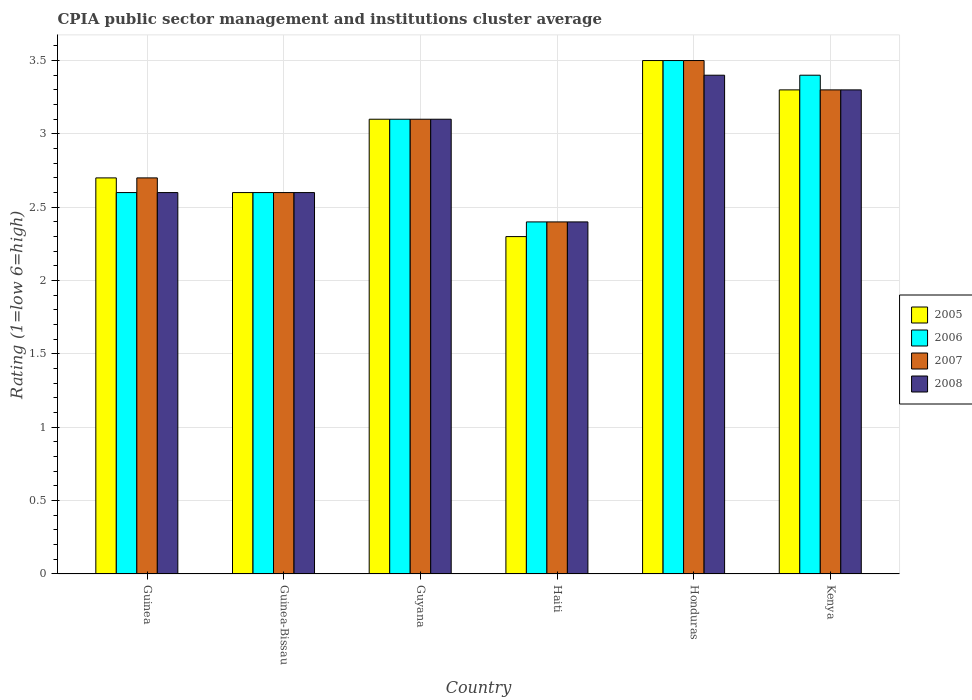Are the number of bars per tick equal to the number of legend labels?
Provide a succinct answer. Yes. Are the number of bars on each tick of the X-axis equal?
Your response must be concise. Yes. How many bars are there on the 1st tick from the left?
Your answer should be compact. 4. What is the label of the 3rd group of bars from the left?
Give a very brief answer. Guyana. In how many cases, is the number of bars for a given country not equal to the number of legend labels?
Offer a terse response. 0. What is the CPIA rating in 2005 in Guinea-Bissau?
Offer a very short reply. 2.6. Across all countries, what is the maximum CPIA rating in 2008?
Your response must be concise. 3.4. Across all countries, what is the minimum CPIA rating in 2008?
Offer a very short reply. 2.4. In which country was the CPIA rating in 2008 maximum?
Ensure brevity in your answer.  Honduras. In which country was the CPIA rating in 2006 minimum?
Provide a short and direct response. Haiti. What is the difference between the CPIA rating in 2005 in Guinea and that in Kenya?
Offer a very short reply. -0.6. What is the difference between the CPIA rating in 2007 in Guyana and the CPIA rating in 2005 in Kenya?
Your answer should be compact. -0.2. What is the average CPIA rating in 2007 per country?
Offer a very short reply. 2.93. What is the ratio of the CPIA rating in 2005 in Haiti to that in Honduras?
Give a very brief answer. 0.66. Is the CPIA rating in 2006 in Guinea less than that in Guyana?
Offer a very short reply. Yes. What is the difference between the highest and the second highest CPIA rating in 2007?
Your answer should be very brief. -0.2. In how many countries, is the CPIA rating in 2005 greater than the average CPIA rating in 2005 taken over all countries?
Your answer should be very brief. 3. What does the 1st bar from the right in Kenya represents?
Make the answer very short. 2008. How many bars are there?
Make the answer very short. 24. Are all the bars in the graph horizontal?
Ensure brevity in your answer.  No. What is the difference between two consecutive major ticks on the Y-axis?
Provide a short and direct response. 0.5. Does the graph contain any zero values?
Ensure brevity in your answer.  No. Where does the legend appear in the graph?
Make the answer very short. Center right. How many legend labels are there?
Your response must be concise. 4. How are the legend labels stacked?
Provide a succinct answer. Vertical. What is the title of the graph?
Keep it short and to the point. CPIA public sector management and institutions cluster average. Does "1972" appear as one of the legend labels in the graph?
Ensure brevity in your answer.  No. What is the label or title of the X-axis?
Your response must be concise. Country. What is the Rating (1=low 6=high) in 2005 in Guinea?
Keep it short and to the point. 2.7. What is the Rating (1=low 6=high) of 2006 in Guinea?
Provide a succinct answer. 2.6. What is the Rating (1=low 6=high) of 2008 in Guinea?
Ensure brevity in your answer.  2.6. What is the Rating (1=low 6=high) in 2006 in Guinea-Bissau?
Offer a terse response. 2.6. What is the Rating (1=low 6=high) in 2008 in Guinea-Bissau?
Provide a succinct answer. 2.6. What is the Rating (1=low 6=high) in 2005 in Haiti?
Provide a succinct answer. 2.3. What is the Rating (1=low 6=high) in 2008 in Haiti?
Your response must be concise. 2.4. Across all countries, what is the minimum Rating (1=low 6=high) in 2005?
Offer a terse response. 2.3. Across all countries, what is the minimum Rating (1=low 6=high) of 2006?
Provide a short and direct response. 2.4. Across all countries, what is the minimum Rating (1=low 6=high) of 2007?
Offer a terse response. 2.4. What is the total Rating (1=low 6=high) of 2006 in the graph?
Give a very brief answer. 17.6. What is the total Rating (1=low 6=high) of 2008 in the graph?
Make the answer very short. 17.4. What is the difference between the Rating (1=low 6=high) in 2006 in Guinea and that in Guinea-Bissau?
Offer a very short reply. 0. What is the difference between the Rating (1=low 6=high) of 2007 in Guinea and that in Guinea-Bissau?
Make the answer very short. 0.1. What is the difference between the Rating (1=low 6=high) of 2008 in Guinea and that in Guinea-Bissau?
Offer a very short reply. 0. What is the difference between the Rating (1=low 6=high) of 2006 in Guinea and that in Haiti?
Provide a short and direct response. 0.2. What is the difference between the Rating (1=low 6=high) of 2007 in Guinea and that in Haiti?
Keep it short and to the point. 0.3. What is the difference between the Rating (1=low 6=high) of 2006 in Guinea and that in Honduras?
Ensure brevity in your answer.  -0.9. What is the difference between the Rating (1=low 6=high) in 2007 in Guinea and that in Honduras?
Your answer should be compact. -0.8. What is the difference between the Rating (1=low 6=high) of 2008 in Guinea and that in Honduras?
Ensure brevity in your answer.  -0.8. What is the difference between the Rating (1=low 6=high) in 2005 in Guinea and that in Kenya?
Provide a short and direct response. -0.6. What is the difference between the Rating (1=low 6=high) in 2006 in Guinea and that in Kenya?
Provide a succinct answer. -0.8. What is the difference between the Rating (1=low 6=high) of 2008 in Guinea and that in Kenya?
Your response must be concise. -0.7. What is the difference between the Rating (1=low 6=high) in 2005 in Guinea-Bissau and that in Guyana?
Give a very brief answer. -0.5. What is the difference between the Rating (1=low 6=high) in 2006 in Guinea-Bissau and that in Guyana?
Your answer should be compact. -0.5. What is the difference between the Rating (1=low 6=high) of 2005 in Guinea-Bissau and that in Haiti?
Your answer should be compact. 0.3. What is the difference between the Rating (1=low 6=high) in 2007 in Guinea-Bissau and that in Haiti?
Provide a short and direct response. 0.2. What is the difference between the Rating (1=low 6=high) of 2008 in Guinea-Bissau and that in Haiti?
Provide a short and direct response. 0.2. What is the difference between the Rating (1=low 6=high) in 2005 in Guinea-Bissau and that in Kenya?
Ensure brevity in your answer.  -0.7. What is the difference between the Rating (1=low 6=high) in 2006 in Guinea-Bissau and that in Kenya?
Make the answer very short. -0.8. What is the difference between the Rating (1=low 6=high) of 2008 in Guinea-Bissau and that in Kenya?
Give a very brief answer. -0.7. What is the difference between the Rating (1=low 6=high) of 2006 in Guyana and that in Haiti?
Ensure brevity in your answer.  0.7. What is the difference between the Rating (1=low 6=high) of 2008 in Guyana and that in Haiti?
Your answer should be very brief. 0.7. What is the difference between the Rating (1=low 6=high) of 2006 in Guyana and that in Honduras?
Ensure brevity in your answer.  -0.4. What is the difference between the Rating (1=low 6=high) in 2007 in Guyana and that in Honduras?
Your answer should be very brief. -0.4. What is the difference between the Rating (1=low 6=high) in 2005 in Guyana and that in Kenya?
Your answer should be compact. -0.2. What is the difference between the Rating (1=low 6=high) of 2007 in Guyana and that in Kenya?
Your response must be concise. -0.2. What is the difference between the Rating (1=low 6=high) of 2006 in Haiti and that in Honduras?
Offer a very short reply. -1.1. What is the difference between the Rating (1=low 6=high) in 2007 in Haiti and that in Honduras?
Offer a very short reply. -1.1. What is the difference between the Rating (1=low 6=high) of 2006 in Haiti and that in Kenya?
Your response must be concise. -1. What is the difference between the Rating (1=low 6=high) of 2007 in Haiti and that in Kenya?
Make the answer very short. -0.9. What is the difference between the Rating (1=low 6=high) of 2008 in Haiti and that in Kenya?
Provide a short and direct response. -0.9. What is the difference between the Rating (1=low 6=high) of 2005 in Honduras and that in Kenya?
Keep it short and to the point. 0.2. What is the difference between the Rating (1=low 6=high) of 2006 in Honduras and that in Kenya?
Offer a very short reply. 0.1. What is the difference between the Rating (1=low 6=high) in 2005 in Guinea and the Rating (1=low 6=high) in 2007 in Guinea-Bissau?
Make the answer very short. 0.1. What is the difference between the Rating (1=low 6=high) of 2005 in Guinea and the Rating (1=low 6=high) of 2008 in Guinea-Bissau?
Your answer should be very brief. 0.1. What is the difference between the Rating (1=low 6=high) of 2006 in Guinea and the Rating (1=low 6=high) of 2007 in Guinea-Bissau?
Provide a short and direct response. 0. What is the difference between the Rating (1=low 6=high) of 2005 in Guinea and the Rating (1=low 6=high) of 2007 in Guyana?
Keep it short and to the point. -0.4. What is the difference between the Rating (1=low 6=high) in 2005 in Guinea and the Rating (1=low 6=high) in 2008 in Guyana?
Your answer should be compact. -0.4. What is the difference between the Rating (1=low 6=high) of 2006 in Guinea and the Rating (1=low 6=high) of 2008 in Guyana?
Give a very brief answer. -0.5. What is the difference between the Rating (1=low 6=high) of 2007 in Guinea and the Rating (1=low 6=high) of 2008 in Guyana?
Your response must be concise. -0.4. What is the difference between the Rating (1=low 6=high) in 2005 in Guinea and the Rating (1=low 6=high) in 2006 in Haiti?
Offer a very short reply. 0.3. What is the difference between the Rating (1=low 6=high) of 2005 in Guinea and the Rating (1=low 6=high) of 2007 in Haiti?
Provide a succinct answer. 0.3. What is the difference between the Rating (1=low 6=high) of 2005 in Guinea and the Rating (1=low 6=high) of 2008 in Haiti?
Your answer should be very brief. 0.3. What is the difference between the Rating (1=low 6=high) of 2006 in Guinea and the Rating (1=low 6=high) of 2007 in Haiti?
Your answer should be compact. 0.2. What is the difference between the Rating (1=low 6=high) of 2006 in Guinea and the Rating (1=low 6=high) of 2008 in Haiti?
Offer a very short reply. 0.2. What is the difference between the Rating (1=low 6=high) of 2007 in Guinea and the Rating (1=low 6=high) of 2008 in Haiti?
Your answer should be very brief. 0.3. What is the difference between the Rating (1=low 6=high) of 2005 in Guinea and the Rating (1=low 6=high) of 2006 in Honduras?
Offer a terse response. -0.8. What is the difference between the Rating (1=low 6=high) in 2005 in Guinea and the Rating (1=low 6=high) in 2007 in Honduras?
Keep it short and to the point. -0.8. What is the difference between the Rating (1=low 6=high) in 2006 in Guinea and the Rating (1=low 6=high) in 2007 in Honduras?
Give a very brief answer. -0.9. What is the difference between the Rating (1=low 6=high) in 2007 in Guinea and the Rating (1=low 6=high) in 2008 in Honduras?
Provide a short and direct response. -0.7. What is the difference between the Rating (1=low 6=high) of 2005 in Guinea and the Rating (1=low 6=high) of 2008 in Kenya?
Ensure brevity in your answer.  -0.6. What is the difference between the Rating (1=low 6=high) of 2006 in Guinea and the Rating (1=low 6=high) of 2007 in Kenya?
Provide a short and direct response. -0.7. What is the difference between the Rating (1=low 6=high) in 2005 in Guinea-Bissau and the Rating (1=low 6=high) in 2008 in Guyana?
Provide a succinct answer. -0.5. What is the difference between the Rating (1=low 6=high) of 2006 in Guinea-Bissau and the Rating (1=low 6=high) of 2007 in Guyana?
Make the answer very short. -0.5. What is the difference between the Rating (1=low 6=high) of 2007 in Guinea-Bissau and the Rating (1=low 6=high) of 2008 in Guyana?
Keep it short and to the point. -0.5. What is the difference between the Rating (1=low 6=high) of 2005 in Guinea-Bissau and the Rating (1=low 6=high) of 2008 in Haiti?
Your answer should be compact. 0.2. What is the difference between the Rating (1=low 6=high) of 2006 in Guinea-Bissau and the Rating (1=low 6=high) of 2008 in Haiti?
Provide a short and direct response. 0.2. What is the difference between the Rating (1=low 6=high) of 2005 in Guinea-Bissau and the Rating (1=low 6=high) of 2006 in Honduras?
Offer a very short reply. -0.9. What is the difference between the Rating (1=low 6=high) of 2006 in Guinea-Bissau and the Rating (1=low 6=high) of 2007 in Honduras?
Keep it short and to the point. -0.9. What is the difference between the Rating (1=low 6=high) in 2006 in Guinea-Bissau and the Rating (1=low 6=high) in 2008 in Honduras?
Provide a succinct answer. -0.8. What is the difference between the Rating (1=low 6=high) in 2005 in Guinea-Bissau and the Rating (1=low 6=high) in 2006 in Kenya?
Provide a short and direct response. -0.8. What is the difference between the Rating (1=low 6=high) of 2006 in Guinea-Bissau and the Rating (1=low 6=high) of 2007 in Kenya?
Offer a terse response. -0.7. What is the difference between the Rating (1=low 6=high) of 2005 in Guyana and the Rating (1=low 6=high) of 2006 in Haiti?
Provide a succinct answer. 0.7. What is the difference between the Rating (1=low 6=high) in 2005 in Guyana and the Rating (1=low 6=high) in 2007 in Haiti?
Provide a short and direct response. 0.7. What is the difference between the Rating (1=low 6=high) in 2005 in Guyana and the Rating (1=low 6=high) in 2008 in Haiti?
Offer a very short reply. 0.7. What is the difference between the Rating (1=low 6=high) in 2006 in Guyana and the Rating (1=low 6=high) in 2007 in Haiti?
Offer a terse response. 0.7. What is the difference between the Rating (1=low 6=high) of 2006 in Guyana and the Rating (1=low 6=high) of 2008 in Haiti?
Make the answer very short. 0.7. What is the difference between the Rating (1=low 6=high) of 2007 in Guyana and the Rating (1=low 6=high) of 2008 in Haiti?
Your answer should be compact. 0.7. What is the difference between the Rating (1=low 6=high) in 2005 in Guyana and the Rating (1=low 6=high) in 2007 in Honduras?
Keep it short and to the point. -0.4. What is the difference between the Rating (1=low 6=high) in 2005 in Guyana and the Rating (1=low 6=high) in 2008 in Honduras?
Make the answer very short. -0.3. What is the difference between the Rating (1=low 6=high) in 2006 in Guyana and the Rating (1=low 6=high) in 2007 in Honduras?
Your answer should be very brief. -0.4. What is the difference between the Rating (1=low 6=high) in 2007 in Guyana and the Rating (1=low 6=high) in 2008 in Honduras?
Offer a terse response. -0.3. What is the difference between the Rating (1=low 6=high) in 2005 in Guyana and the Rating (1=low 6=high) in 2006 in Kenya?
Ensure brevity in your answer.  -0.3. What is the difference between the Rating (1=low 6=high) in 2005 in Guyana and the Rating (1=low 6=high) in 2007 in Kenya?
Provide a short and direct response. -0.2. What is the difference between the Rating (1=low 6=high) of 2005 in Guyana and the Rating (1=low 6=high) of 2008 in Kenya?
Offer a very short reply. -0.2. What is the difference between the Rating (1=low 6=high) in 2006 in Guyana and the Rating (1=low 6=high) in 2007 in Kenya?
Your answer should be compact. -0.2. What is the difference between the Rating (1=low 6=high) of 2005 in Haiti and the Rating (1=low 6=high) of 2006 in Honduras?
Provide a succinct answer. -1.2. What is the difference between the Rating (1=low 6=high) in 2005 in Haiti and the Rating (1=low 6=high) in 2007 in Honduras?
Provide a short and direct response. -1.2. What is the difference between the Rating (1=low 6=high) in 2007 in Haiti and the Rating (1=low 6=high) in 2008 in Honduras?
Offer a terse response. -1. What is the difference between the Rating (1=low 6=high) in 2005 in Haiti and the Rating (1=low 6=high) in 2006 in Kenya?
Your response must be concise. -1.1. What is the difference between the Rating (1=low 6=high) of 2006 in Honduras and the Rating (1=low 6=high) of 2007 in Kenya?
Offer a terse response. 0.2. What is the difference between the Rating (1=low 6=high) of 2006 in Honduras and the Rating (1=low 6=high) of 2008 in Kenya?
Provide a short and direct response. 0.2. What is the difference between the Rating (1=low 6=high) of 2007 in Honduras and the Rating (1=low 6=high) of 2008 in Kenya?
Provide a succinct answer. 0.2. What is the average Rating (1=low 6=high) of 2005 per country?
Ensure brevity in your answer.  2.92. What is the average Rating (1=low 6=high) of 2006 per country?
Your answer should be very brief. 2.93. What is the average Rating (1=low 6=high) of 2007 per country?
Provide a short and direct response. 2.93. What is the difference between the Rating (1=low 6=high) in 2005 and Rating (1=low 6=high) in 2007 in Guinea?
Your answer should be very brief. 0. What is the difference between the Rating (1=low 6=high) in 2005 and Rating (1=low 6=high) in 2008 in Guinea?
Keep it short and to the point. 0.1. What is the difference between the Rating (1=low 6=high) of 2005 and Rating (1=low 6=high) of 2008 in Guinea-Bissau?
Ensure brevity in your answer.  0. What is the difference between the Rating (1=low 6=high) of 2006 and Rating (1=low 6=high) of 2007 in Guinea-Bissau?
Give a very brief answer. 0. What is the difference between the Rating (1=low 6=high) in 2006 and Rating (1=low 6=high) in 2008 in Guinea-Bissau?
Your answer should be compact. 0. What is the difference between the Rating (1=low 6=high) of 2006 and Rating (1=low 6=high) of 2008 in Guyana?
Ensure brevity in your answer.  0. What is the difference between the Rating (1=low 6=high) in 2005 and Rating (1=low 6=high) in 2008 in Haiti?
Give a very brief answer. -0.1. What is the difference between the Rating (1=low 6=high) of 2006 and Rating (1=low 6=high) of 2008 in Haiti?
Your response must be concise. 0. What is the difference between the Rating (1=low 6=high) in 2005 and Rating (1=low 6=high) in 2007 in Honduras?
Your answer should be very brief. 0. What is the difference between the Rating (1=low 6=high) in 2005 and Rating (1=low 6=high) in 2007 in Kenya?
Your answer should be very brief. 0. What is the difference between the Rating (1=low 6=high) in 2006 and Rating (1=low 6=high) in 2007 in Kenya?
Your response must be concise. 0.1. What is the difference between the Rating (1=low 6=high) in 2006 and Rating (1=low 6=high) in 2008 in Kenya?
Provide a succinct answer. 0.1. What is the ratio of the Rating (1=low 6=high) in 2006 in Guinea to that in Guinea-Bissau?
Keep it short and to the point. 1. What is the ratio of the Rating (1=low 6=high) of 2007 in Guinea to that in Guinea-Bissau?
Offer a terse response. 1.04. What is the ratio of the Rating (1=low 6=high) in 2008 in Guinea to that in Guinea-Bissau?
Provide a succinct answer. 1. What is the ratio of the Rating (1=low 6=high) in 2005 in Guinea to that in Guyana?
Provide a succinct answer. 0.87. What is the ratio of the Rating (1=low 6=high) in 2006 in Guinea to that in Guyana?
Give a very brief answer. 0.84. What is the ratio of the Rating (1=low 6=high) in 2007 in Guinea to that in Guyana?
Ensure brevity in your answer.  0.87. What is the ratio of the Rating (1=low 6=high) of 2008 in Guinea to that in Guyana?
Offer a very short reply. 0.84. What is the ratio of the Rating (1=low 6=high) in 2005 in Guinea to that in Haiti?
Keep it short and to the point. 1.17. What is the ratio of the Rating (1=low 6=high) in 2007 in Guinea to that in Haiti?
Your response must be concise. 1.12. What is the ratio of the Rating (1=low 6=high) in 2005 in Guinea to that in Honduras?
Your answer should be very brief. 0.77. What is the ratio of the Rating (1=low 6=high) in 2006 in Guinea to that in Honduras?
Your answer should be very brief. 0.74. What is the ratio of the Rating (1=low 6=high) in 2007 in Guinea to that in Honduras?
Ensure brevity in your answer.  0.77. What is the ratio of the Rating (1=low 6=high) of 2008 in Guinea to that in Honduras?
Your answer should be very brief. 0.76. What is the ratio of the Rating (1=low 6=high) in 2005 in Guinea to that in Kenya?
Provide a short and direct response. 0.82. What is the ratio of the Rating (1=low 6=high) in 2006 in Guinea to that in Kenya?
Offer a terse response. 0.76. What is the ratio of the Rating (1=low 6=high) of 2007 in Guinea to that in Kenya?
Offer a very short reply. 0.82. What is the ratio of the Rating (1=low 6=high) in 2008 in Guinea to that in Kenya?
Your answer should be compact. 0.79. What is the ratio of the Rating (1=low 6=high) in 2005 in Guinea-Bissau to that in Guyana?
Your answer should be compact. 0.84. What is the ratio of the Rating (1=low 6=high) in 2006 in Guinea-Bissau to that in Guyana?
Your answer should be compact. 0.84. What is the ratio of the Rating (1=low 6=high) in 2007 in Guinea-Bissau to that in Guyana?
Give a very brief answer. 0.84. What is the ratio of the Rating (1=low 6=high) of 2008 in Guinea-Bissau to that in Guyana?
Ensure brevity in your answer.  0.84. What is the ratio of the Rating (1=low 6=high) in 2005 in Guinea-Bissau to that in Haiti?
Your answer should be very brief. 1.13. What is the ratio of the Rating (1=low 6=high) in 2005 in Guinea-Bissau to that in Honduras?
Offer a very short reply. 0.74. What is the ratio of the Rating (1=low 6=high) in 2006 in Guinea-Bissau to that in Honduras?
Make the answer very short. 0.74. What is the ratio of the Rating (1=low 6=high) in 2007 in Guinea-Bissau to that in Honduras?
Offer a terse response. 0.74. What is the ratio of the Rating (1=low 6=high) of 2008 in Guinea-Bissau to that in Honduras?
Ensure brevity in your answer.  0.76. What is the ratio of the Rating (1=low 6=high) of 2005 in Guinea-Bissau to that in Kenya?
Your response must be concise. 0.79. What is the ratio of the Rating (1=low 6=high) of 2006 in Guinea-Bissau to that in Kenya?
Ensure brevity in your answer.  0.76. What is the ratio of the Rating (1=low 6=high) in 2007 in Guinea-Bissau to that in Kenya?
Your response must be concise. 0.79. What is the ratio of the Rating (1=low 6=high) in 2008 in Guinea-Bissau to that in Kenya?
Your answer should be very brief. 0.79. What is the ratio of the Rating (1=low 6=high) in 2005 in Guyana to that in Haiti?
Make the answer very short. 1.35. What is the ratio of the Rating (1=low 6=high) in 2006 in Guyana to that in Haiti?
Provide a succinct answer. 1.29. What is the ratio of the Rating (1=low 6=high) of 2007 in Guyana to that in Haiti?
Offer a very short reply. 1.29. What is the ratio of the Rating (1=low 6=high) of 2008 in Guyana to that in Haiti?
Provide a short and direct response. 1.29. What is the ratio of the Rating (1=low 6=high) of 2005 in Guyana to that in Honduras?
Provide a short and direct response. 0.89. What is the ratio of the Rating (1=low 6=high) in 2006 in Guyana to that in Honduras?
Offer a very short reply. 0.89. What is the ratio of the Rating (1=low 6=high) in 2007 in Guyana to that in Honduras?
Provide a succinct answer. 0.89. What is the ratio of the Rating (1=low 6=high) of 2008 in Guyana to that in Honduras?
Make the answer very short. 0.91. What is the ratio of the Rating (1=low 6=high) of 2005 in Guyana to that in Kenya?
Make the answer very short. 0.94. What is the ratio of the Rating (1=low 6=high) of 2006 in Guyana to that in Kenya?
Your answer should be compact. 0.91. What is the ratio of the Rating (1=low 6=high) in 2007 in Guyana to that in Kenya?
Ensure brevity in your answer.  0.94. What is the ratio of the Rating (1=low 6=high) in 2008 in Guyana to that in Kenya?
Your answer should be very brief. 0.94. What is the ratio of the Rating (1=low 6=high) in 2005 in Haiti to that in Honduras?
Your answer should be compact. 0.66. What is the ratio of the Rating (1=low 6=high) of 2006 in Haiti to that in Honduras?
Ensure brevity in your answer.  0.69. What is the ratio of the Rating (1=low 6=high) of 2007 in Haiti to that in Honduras?
Make the answer very short. 0.69. What is the ratio of the Rating (1=low 6=high) of 2008 in Haiti to that in Honduras?
Provide a short and direct response. 0.71. What is the ratio of the Rating (1=low 6=high) in 2005 in Haiti to that in Kenya?
Ensure brevity in your answer.  0.7. What is the ratio of the Rating (1=low 6=high) of 2006 in Haiti to that in Kenya?
Keep it short and to the point. 0.71. What is the ratio of the Rating (1=low 6=high) of 2007 in Haiti to that in Kenya?
Provide a succinct answer. 0.73. What is the ratio of the Rating (1=low 6=high) of 2008 in Haiti to that in Kenya?
Make the answer very short. 0.73. What is the ratio of the Rating (1=low 6=high) in 2005 in Honduras to that in Kenya?
Your response must be concise. 1.06. What is the ratio of the Rating (1=low 6=high) in 2006 in Honduras to that in Kenya?
Your answer should be very brief. 1.03. What is the ratio of the Rating (1=low 6=high) in 2007 in Honduras to that in Kenya?
Provide a succinct answer. 1.06. What is the ratio of the Rating (1=low 6=high) of 2008 in Honduras to that in Kenya?
Provide a short and direct response. 1.03. What is the difference between the highest and the second highest Rating (1=low 6=high) in 2005?
Make the answer very short. 0.2. What is the difference between the highest and the second highest Rating (1=low 6=high) of 2007?
Provide a succinct answer. 0.2. What is the difference between the highest and the second highest Rating (1=low 6=high) in 2008?
Provide a succinct answer. 0.1. What is the difference between the highest and the lowest Rating (1=low 6=high) in 2005?
Provide a succinct answer. 1.2. What is the difference between the highest and the lowest Rating (1=low 6=high) in 2006?
Offer a very short reply. 1.1. 